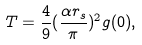<formula> <loc_0><loc_0><loc_500><loc_500>T = \frac { 4 } { 9 } ( \frac { \alpha r _ { s } } { \pi } ) ^ { 2 } g ( 0 ) ,</formula> 